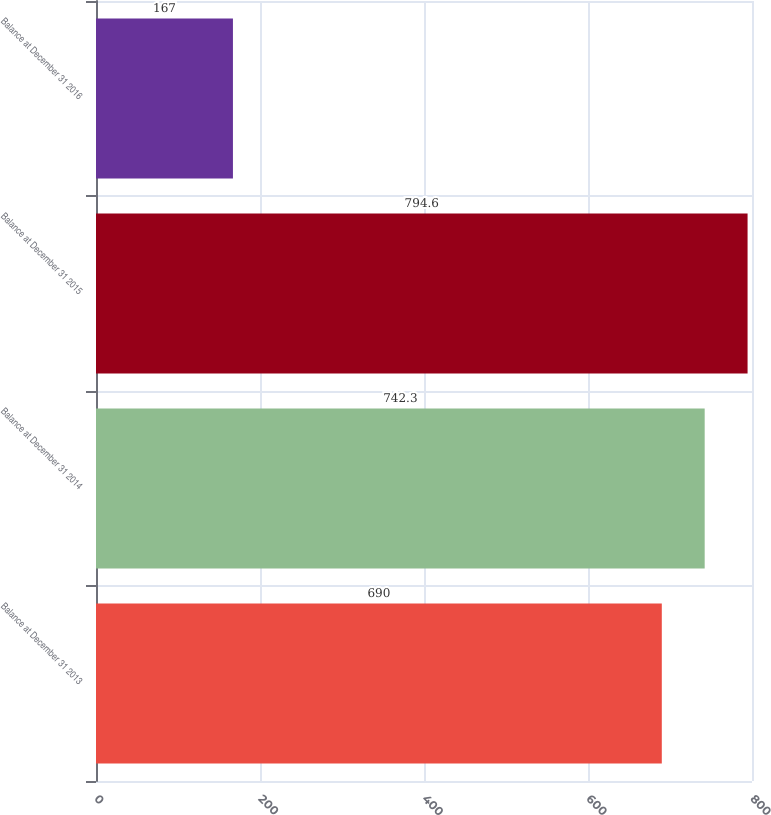<chart> <loc_0><loc_0><loc_500><loc_500><bar_chart><fcel>Balance at December 31 2013<fcel>Balance at December 31 2014<fcel>Balance at December 31 2015<fcel>Balance at December 31 2016<nl><fcel>690<fcel>742.3<fcel>794.6<fcel>167<nl></chart> 